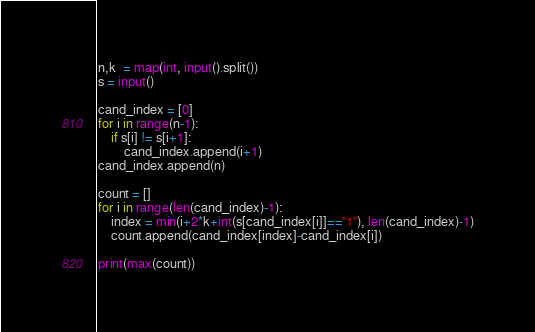Convert code to text. <code><loc_0><loc_0><loc_500><loc_500><_Python_>n,k  = map(int, input().split())
s = input()

cand_index = [0] 
for i in range(n-1):
    if s[i] != s[i+1]:
        cand_index.append(i+1)
cand_index.append(n)

count = []
for i in range(len(cand_index)-1):
    index = min(i+2*k+int(s[cand_index[i]]=="1"), len(cand_index)-1)
    count.append(cand_index[index]-cand_index[i])
        
print(max(count))</code> 